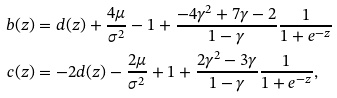<formula> <loc_0><loc_0><loc_500><loc_500>b ( z ) & = d ( z ) + \frac { 4 \mu } { \sigma ^ { 2 } } - 1 + \frac { - 4 \gamma ^ { 2 } + 7 \gamma - 2 } { 1 - \gamma } \frac { 1 } { 1 + e ^ { - z } } \\ c ( z ) & = - 2 d ( z ) - \frac { 2 \mu } { \sigma ^ { 2 } } + 1 + \frac { 2 \gamma ^ { 2 } - 3 \gamma } { 1 - \gamma } \frac { 1 } { 1 + e ^ { - z } } ,</formula> 